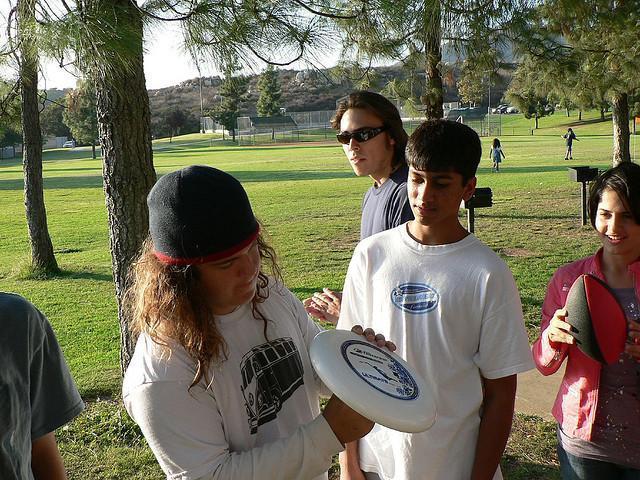How many people are in the picture?
Give a very brief answer. 5. 